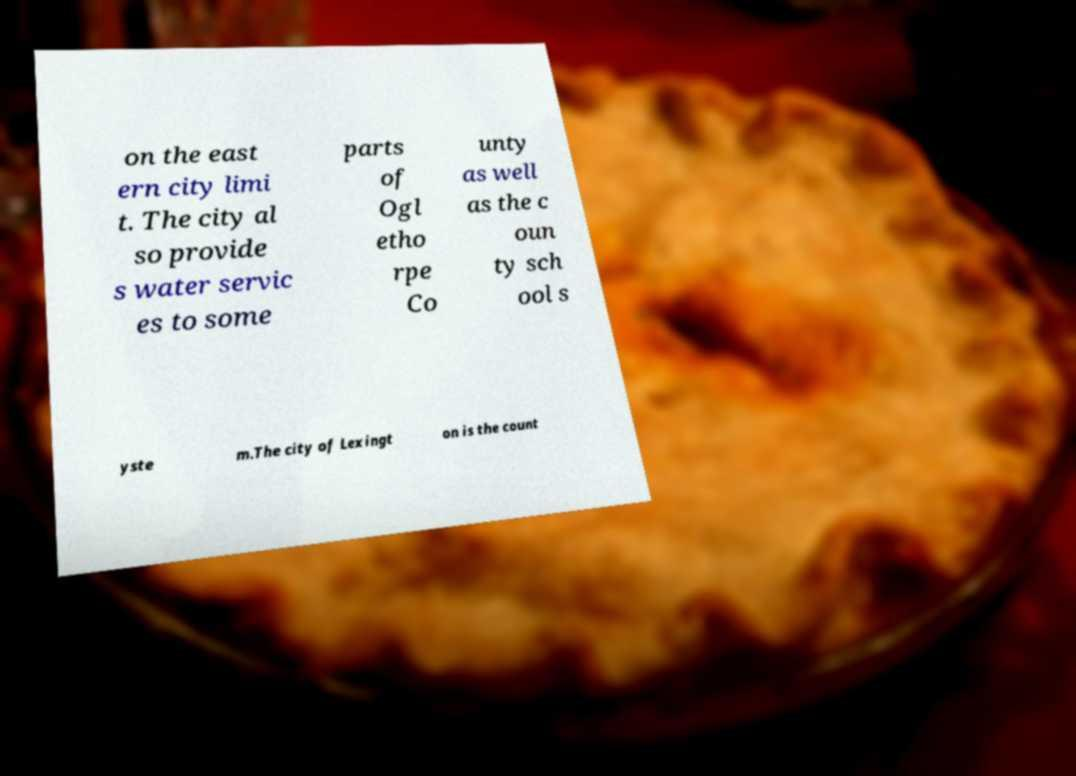What messages or text are displayed in this image? I need them in a readable, typed format. on the east ern city limi t. The city al so provide s water servic es to some parts of Ogl etho rpe Co unty as well as the c oun ty sch ool s yste m.The city of Lexingt on is the count 